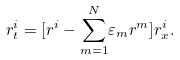Convert formula to latex. <formula><loc_0><loc_0><loc_500><loc_500>r _ { t } ^ { i } = [ r ^ { i } - \underset { m = 1 } { \overset { N } { \sum } } \varepsilon _ { m } r ^ { m } ] r _ { x } ^ { i } .</formula> 